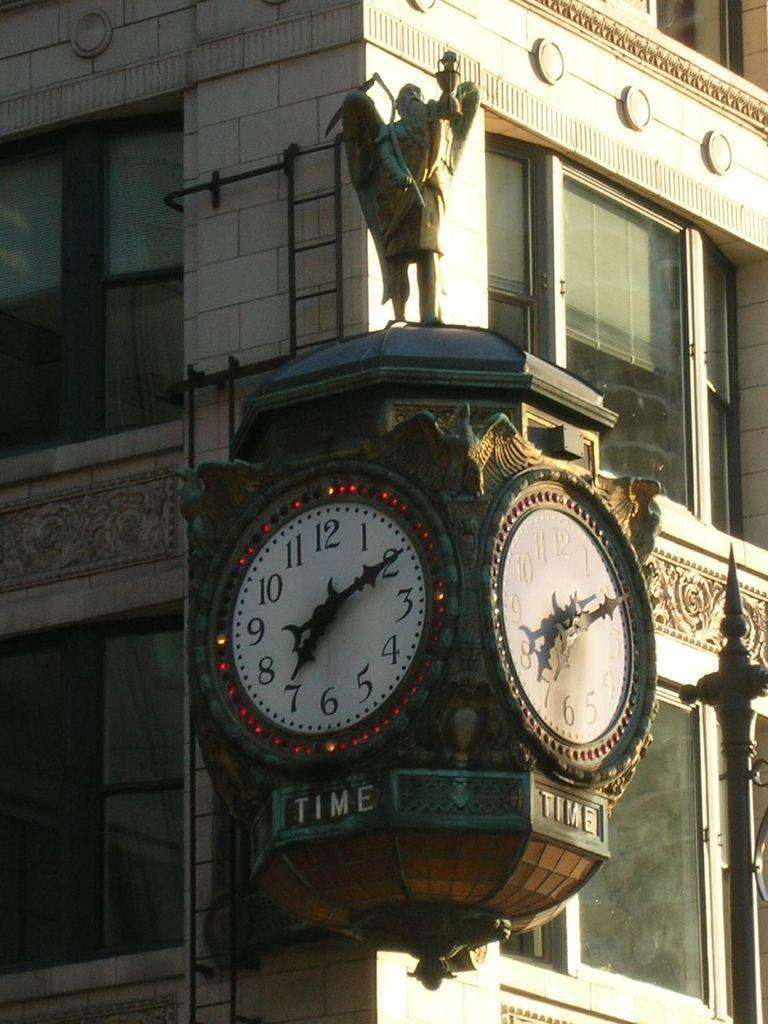<image>
Render a clear and concise summary of the photo. An ornate clock on the corner of a building says Time. 